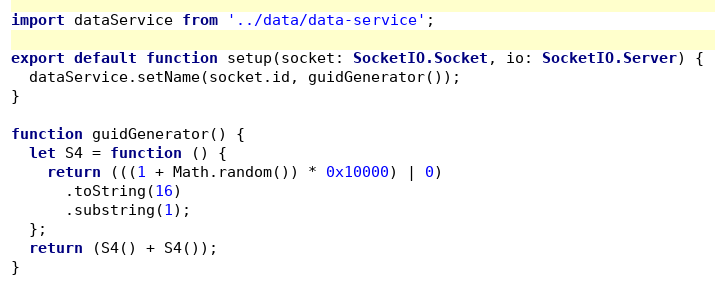Convert code to text. <code><loc_0><loc_0><loc_500><loc_500><_TypeScript_>import dataService from '../data/data-service';

export default function setup(socket: SocketIO.Socket, io: SocketIO.Server) {
  dataService.setName(socket.id, guidGenerator());
}

function guidGenerator() {
  let S4 = function () {
    return (((1 + Math.random()) * 0x10000) | 0)
      .toString(16)
      .substring(1);
  };
  return (S4() + S4());
}
</code> 